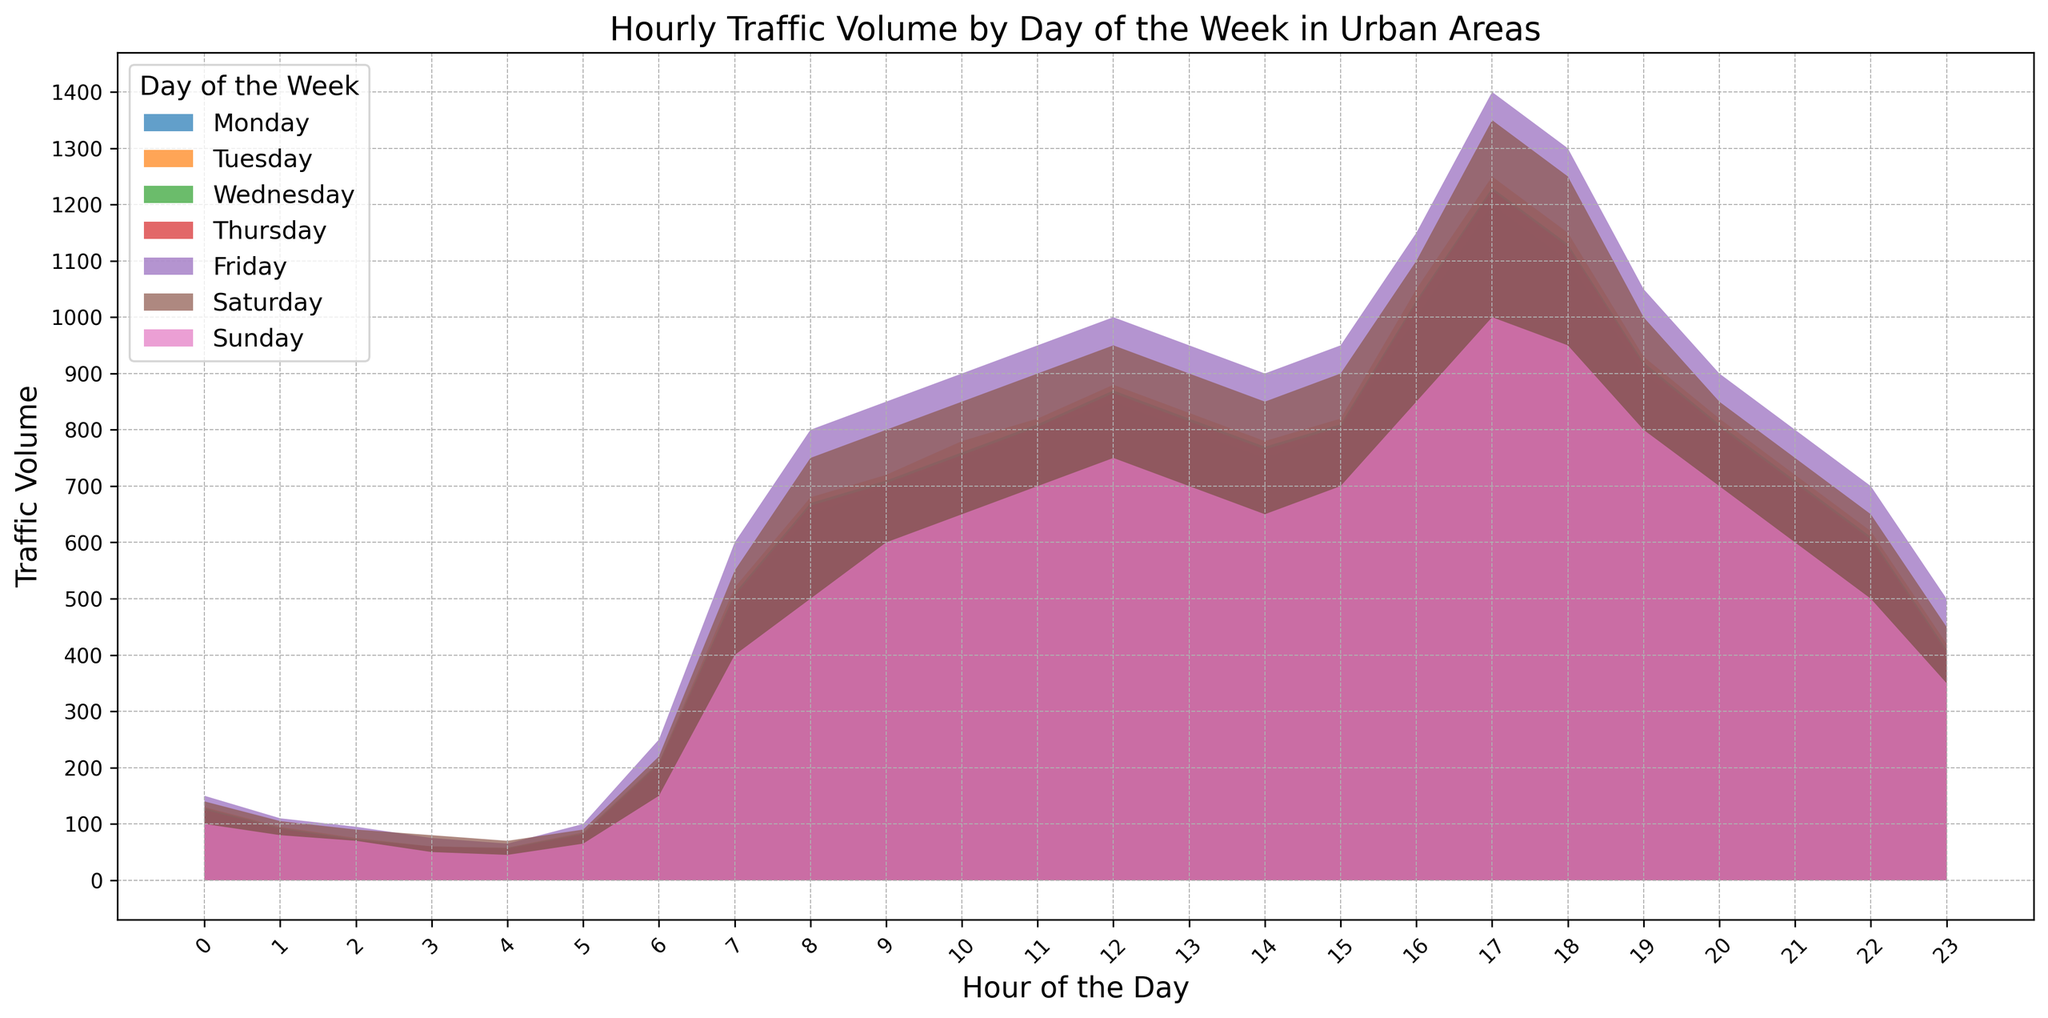Which day has the highest traffic volume at 9 AM? By examining the area chart at the 9 AM mark, we can compare the heights of the different colored regions representing each day. The tallest area at 9 AM indicates the highest traffic volume for that day.
Answer: Friday Which day experiences the lowest traffic volume late at night around 3 AM? Observing the chart around 3 AM, where the colored regions are at their lowest, helps identify the day with the smallest volume. The lowest point indicates the least traffic volume for that time.
Answer: Sunday What is the average traffic volume for Wednesday between 12 PM to 2 PM? To find this, observe the traffic volumes at 12 PM, 1 PM, and 2 PM for Wednesday. Sum these values and divide by the number of hours. 
Values are: 870 (12 PM), 820 (1 PM), 770 (2 PM). 
(870 + 820 + 770) / 3 = 2460 / 3
Answer: 820 Compare the traffic volume trend from 5 AM to 9 AM on Monday with that of Sunday. Which day shows a sharper increase? Review the traffic volume from 5 AM to 9 AM for both Monday and Sunday. For Monday: 80 to 700, and for Sunday: 65 to 600. Calculate the difference for each.
Monday: 700 - 80 = 620
Sunday: 600 - 65 = 535
Monday shows a sharper increase.
Answer: Monday At what hour does the traffic volume peak on Thursday, and what is the peak value? Identify the highest point in the Thursday region of the area chart. This peak generally reflects the maximum traffic volume of the day. The critical point occurs at 5 PM with 1225 vehicles.
Answer: 5 PM, 1225 Which day has the most stable traffic volume throughout the day? To determine this, observe the chart to see which day's region is relatively flat, indicating minor variations in traffic volume.
Answer: Sunday What is the traffic volume differential between 8 AM and 6 PM on Saturday? Note the traffic volumes at 8 AM and 6 PM for Saturday and subtract the earlier value from the later one. 
Values are: 750 (8 AM) and 220 (6 PM).
750 - 220 = 530
Answer: 530 How does the traffic volume on Friday at 11 AM compare to that at 11 PM the same day? Look at the traffic volumes for Friday at 11 AM and 11 PM. Notice that 11 AM has 950 while 11 PM has 500 showing that Friday at 11 AM has higher traffic volume.
Answer: Higher at 11 AM On what day and at what hour does the traffic volume dip below 100 for the first time in the day? Check the chart from left to right until you see the first instance where traffic volumes fall below 100 for any day. This happens for all days around 4 AM.
Answer: Monday through Sunday, around 4 AM 